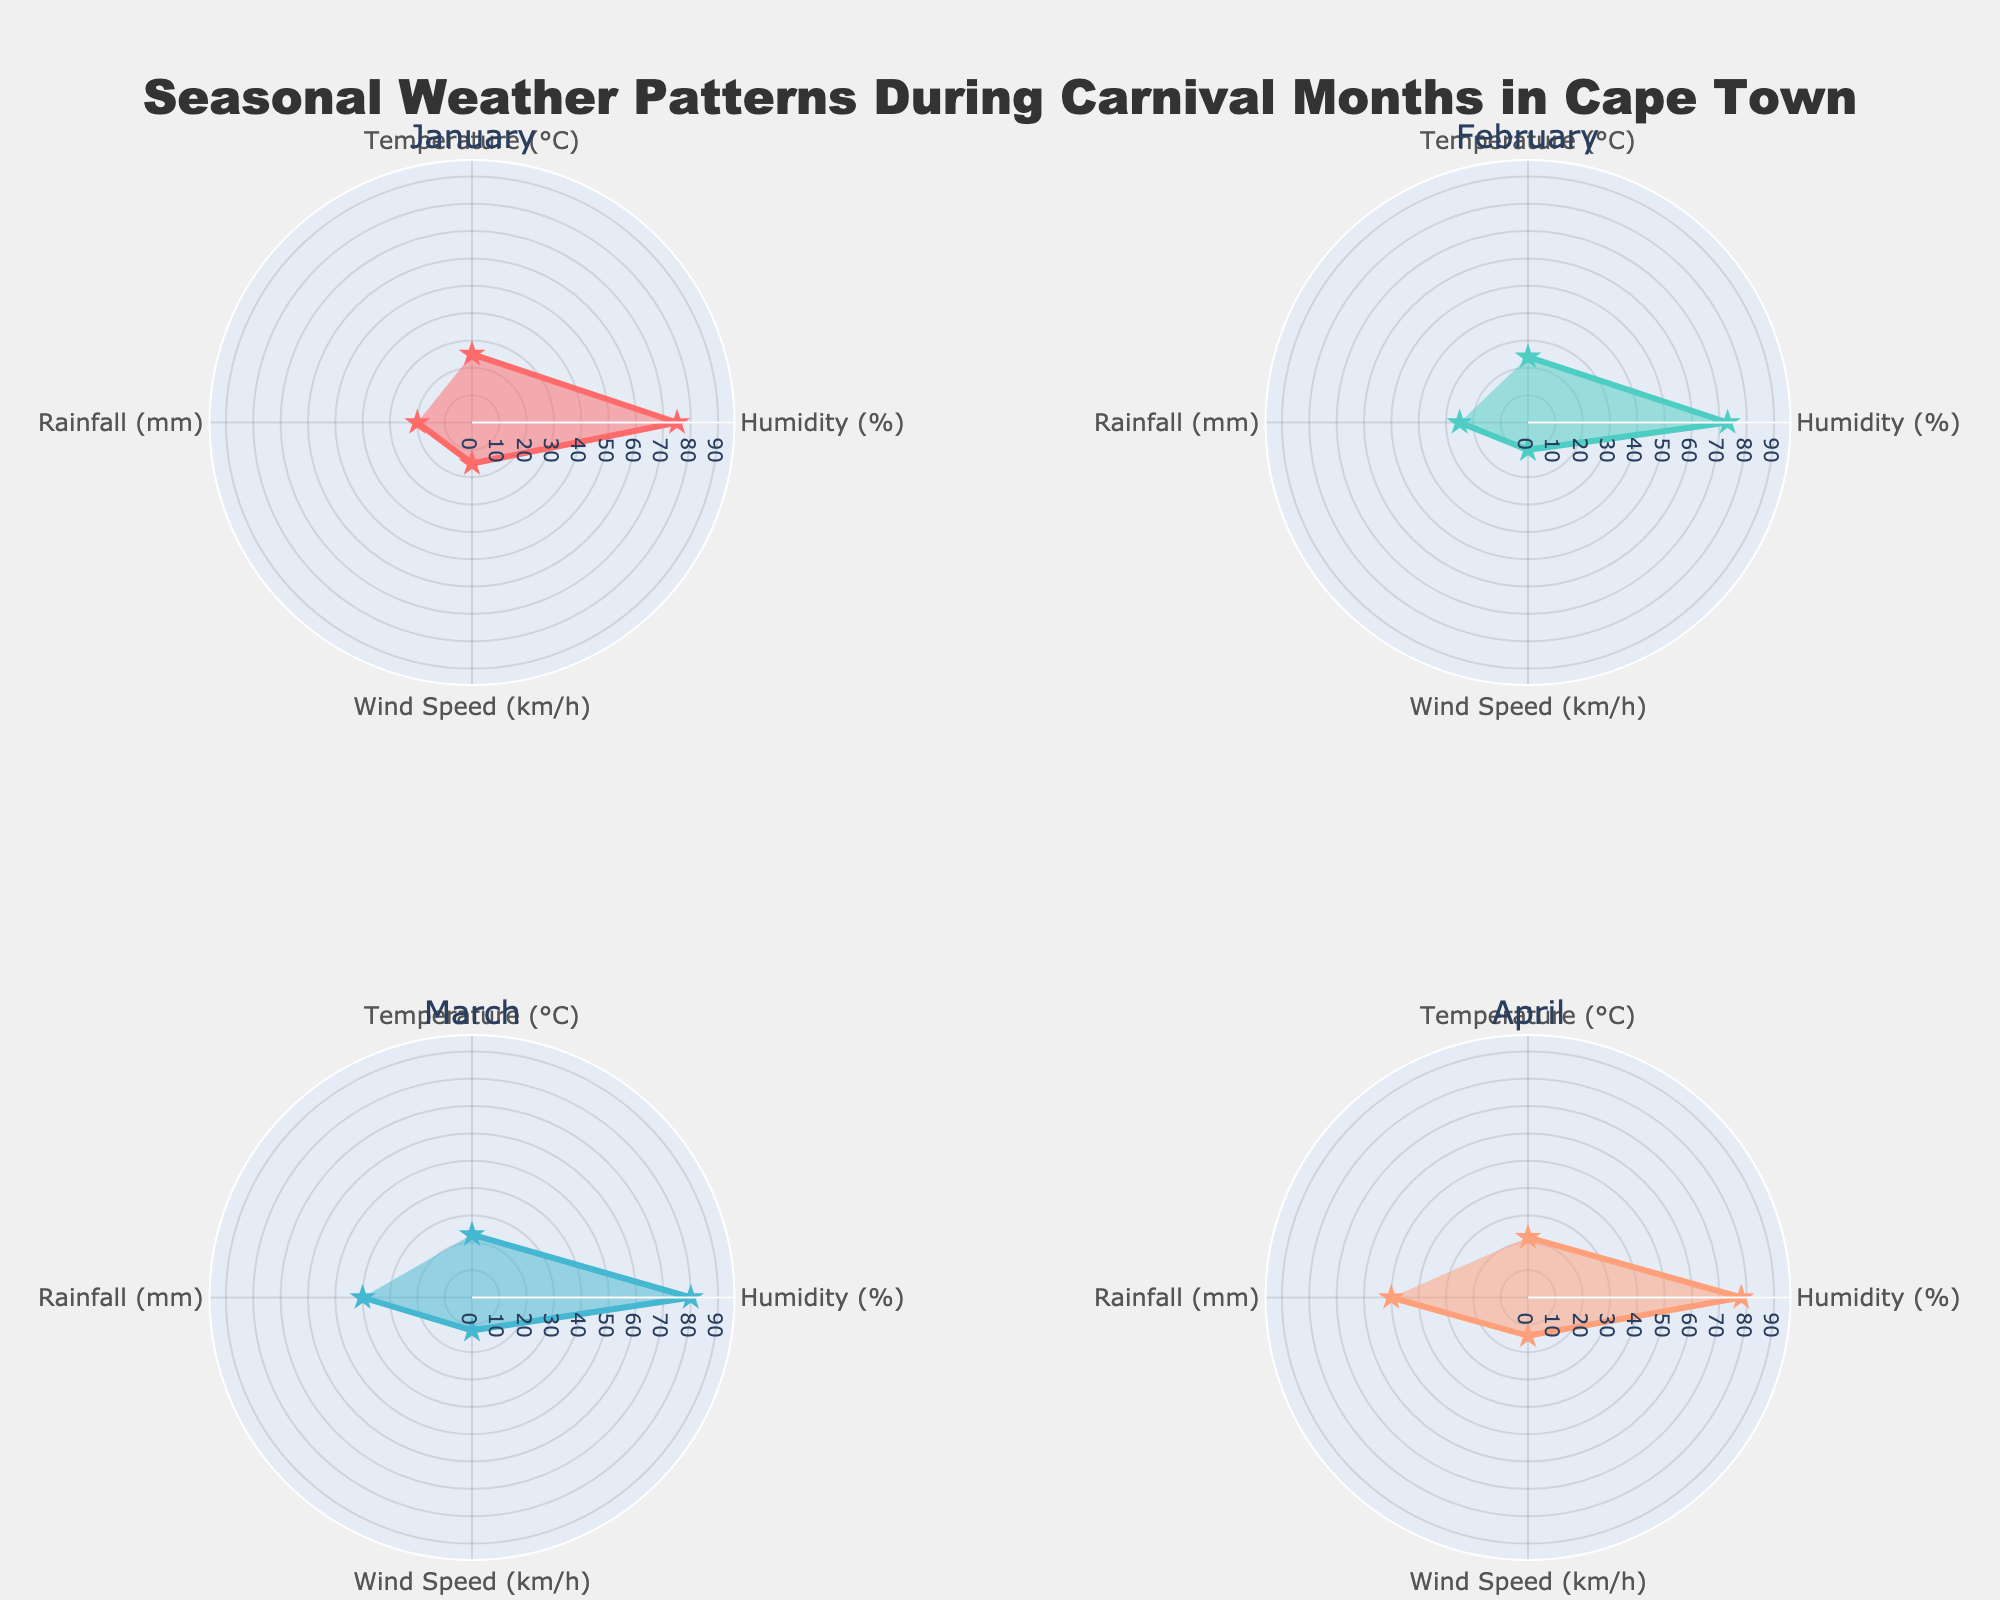What is the title of the figure? The title of a figure is usually placed at the top and provides an overview of what the figure represents. In this case, it reads, "Seasonal Weather Patterns During Carnival Months in Cape Town."
Answer: Seasonal Weather Patterns During Carnival Months in Cape Town In which month is the rainfall the highest? To determine the highest rainfall, look at the radial distance for the rainfall data points (mm) on each subplot. April has the highest radial distance indicating the most rainfall at 50 mm.
Answer: April How many weather attributes are tracked for each month? Each subplot for a month contains markers for different weather attributes. By noting the labels (Temperature, Humidity, Wind Speed, Rainfall), there are four weather attributes tracked.
Answer: 4 Which month shows the lowest temperature? Check each subplot for the data points representing temperature. March has the lowest value at 23°C.
Answer: March Compare the wind speeds in January and February. Which month has the lower wind speed? Look at the subplot for January (15 km/h) and February (10 km/h) for the wind speed data points. February has a lower wind speed than January.
Answer: February Which month has the highest humidity value? Examine each subplot to identify the highest radial distance for the humidity data point. March has the highest humidity at 80%.
Answer: March What is the average temperature across all the months displayed? To find the average, sum the temperatures for January (25), February (24), March (23), and April (22), yielding 94. Then, divide by the number of months: 94 / 4 = 23.5°C.
Answer: 23.5°C Identify the month with the least variance in weather attributes. Observe the shape of each polar chart; the month with the most uniform radial distance for all attributes indicates the least variance. February has the least variance as the distances are more consistent.
Answer: February How does the rainfall in March compare to that in January? By comparing the radial distances for rainfall in the March and January subplots, March has a significantly higher rainfall (40 mm vs. 20 mm).
Answer: March Which month combines the highest temperature with high wind speed? Locate the month with the highest temperature (January, 25°C) and check wind speed (January, 15 km/h). No other month surpasses January's wind speed with the highest temperature.
Answer: January 